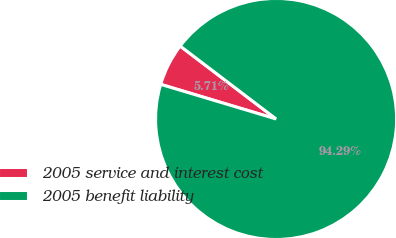Convert chart. <chart><loc_0><loc_0><loc_500><loc_500><pie_chart><fcel>2005 service and interest cost<fcel>2005 benefit liability<nl><fcel>5.71%<fcel>94.29%<nl></chart> 